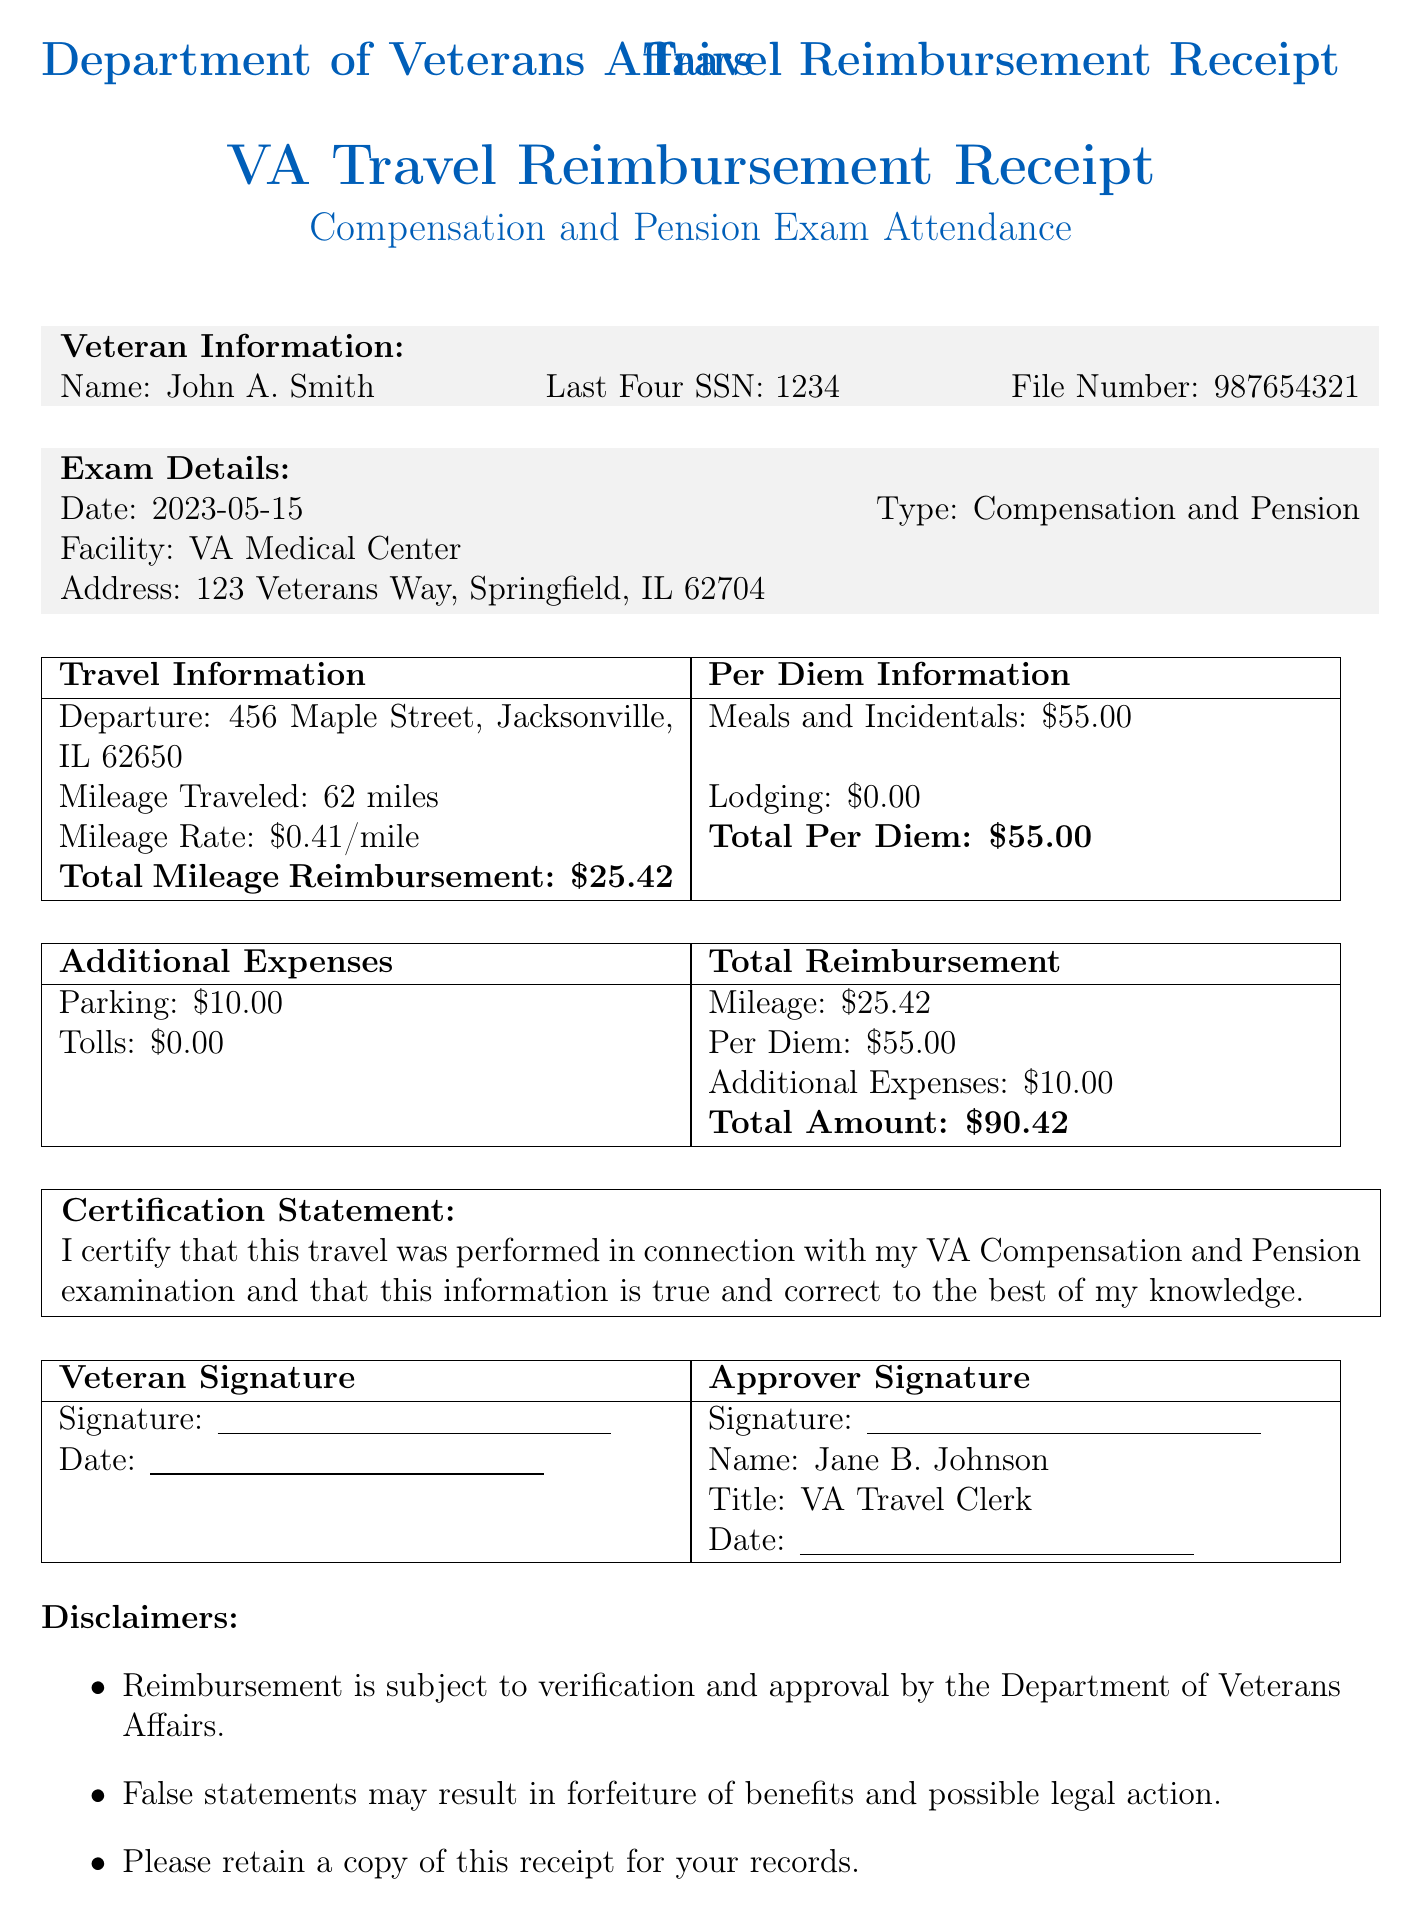What is the veteran's full name? The document provides the name of the veteran as part of the veteran information section.
Answer: John A. Smith What is the date of the exam? The exam date is mentioned in the exam details section of the document.
Answer: 2023-05-15 What is the total mileage reimbursement amount? This information is found in the total reimbursement section, detailing the mileage costs.
Answer: 25.42 How many miles did the veteran travel? The mileage traveled is listed under the travel information section.
Answer: 62 What is the total amount for per diem? The total for per diem is specified in the per diem information section of the document.
Answer: 55.00 Who is the approver of this reimbursement? The approver's name is listed in the signatures section of the document.
Answer: Jane B. Johnson What is the total amount of reimbursement? The total amount is calculated from various components listed in the document, specifically in the total reimbursement section.
Answer: 90.42 What was the veteran's departure address? The departure address is provided in the travel information section of the document.
Answer: 456 Maple Street, Jacksonville, IL 62650 What is the contact email for the travel office? The email contact for the travel office is found at the end of the document under contact information.
Answer: vatravel@va.gov 